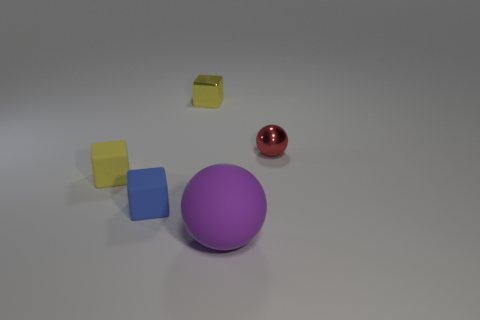Subtract all tiny metallic cubes. How many cubes are left? 2 Subtract all blue blocks. How many blocks are left? 2 Subtract all spheres. How many objects are left? 3 Subtract 2 blocks. How many blocks are left? 1 Subtract 0 brown cubes. How many objects are left? 5 Subtract all gray spheres. Subtract all purple cubes. How many spheres are left? 2 Subtract all red balls. How many blue cubes are left? 1 Subtract all small objects. Subtract all small red metal spheres. How many objects are left? 0 Add 2 big spheres. How many big spheres are left? 3 Add 5 blue matte things. How many blue matte things exist? 6 